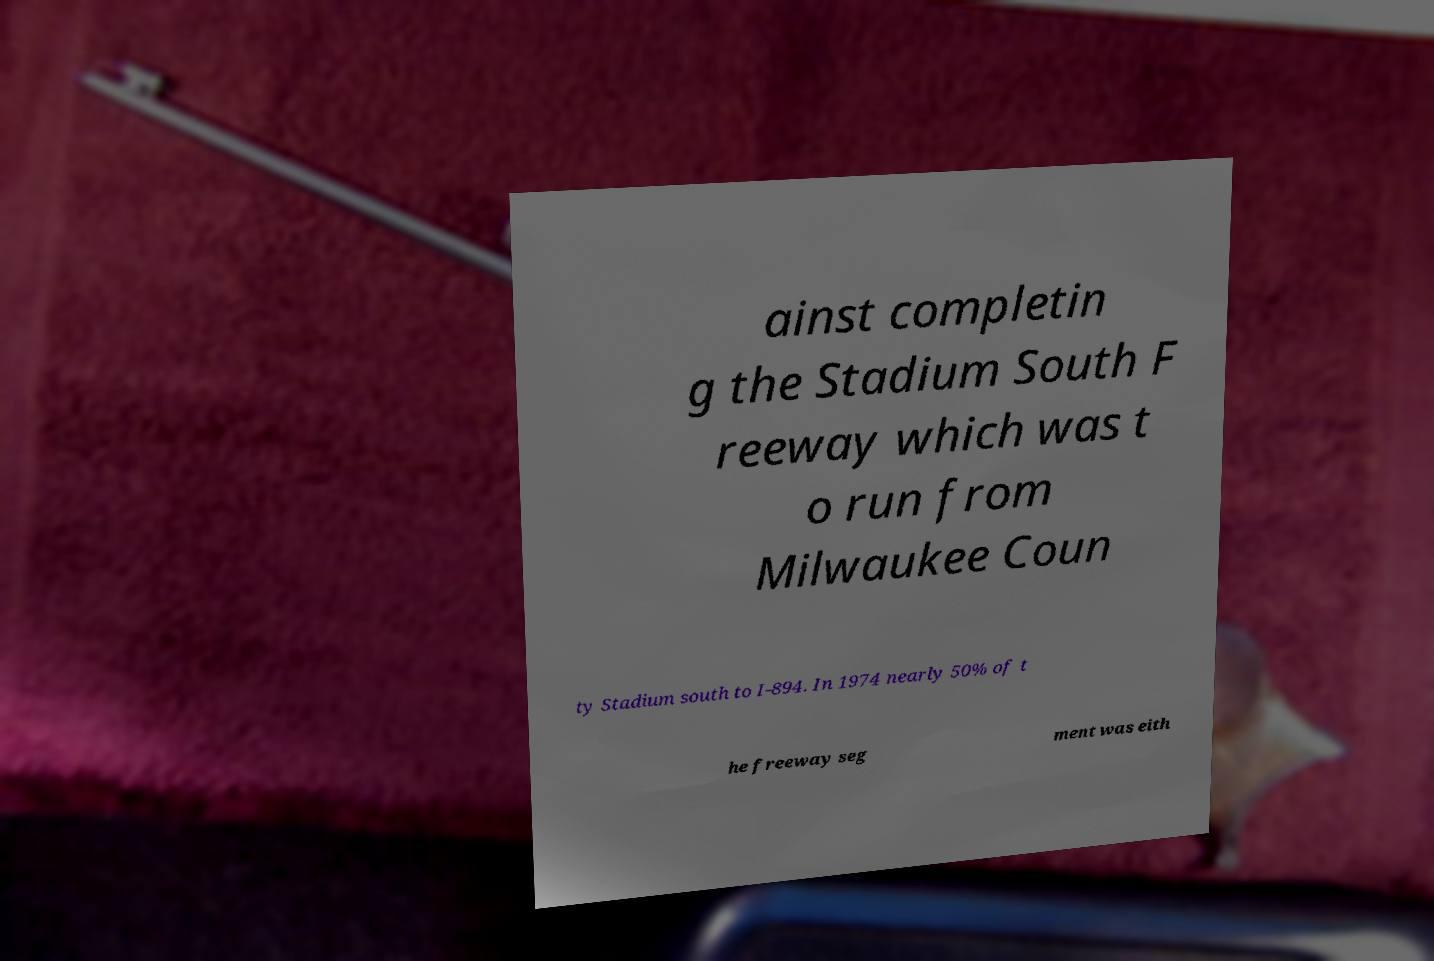Please read and relay the text visible in this image. What does it say? ainst completin g the Stadium South F reeway which was t o run from Milwaukee Coun ty Stadium south to I-894. In 1974 nearly 50% of t he freeway seg ment was eith 